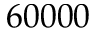Convert formula to latex. <formula><loc_0><loc_0><loc_500><loc_500>6 0 0 0 0</formula> 